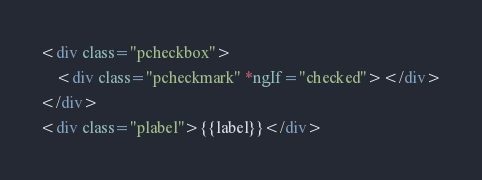Convert code to text. <code><loc_0><loc_0><loc_500><loc_500><_HTML_><div class="pcheckbox">
    <div class="pcheckmark" *ngIf="checked"></div>
</div>
<div class="plabel">{{label}}</div></code> 